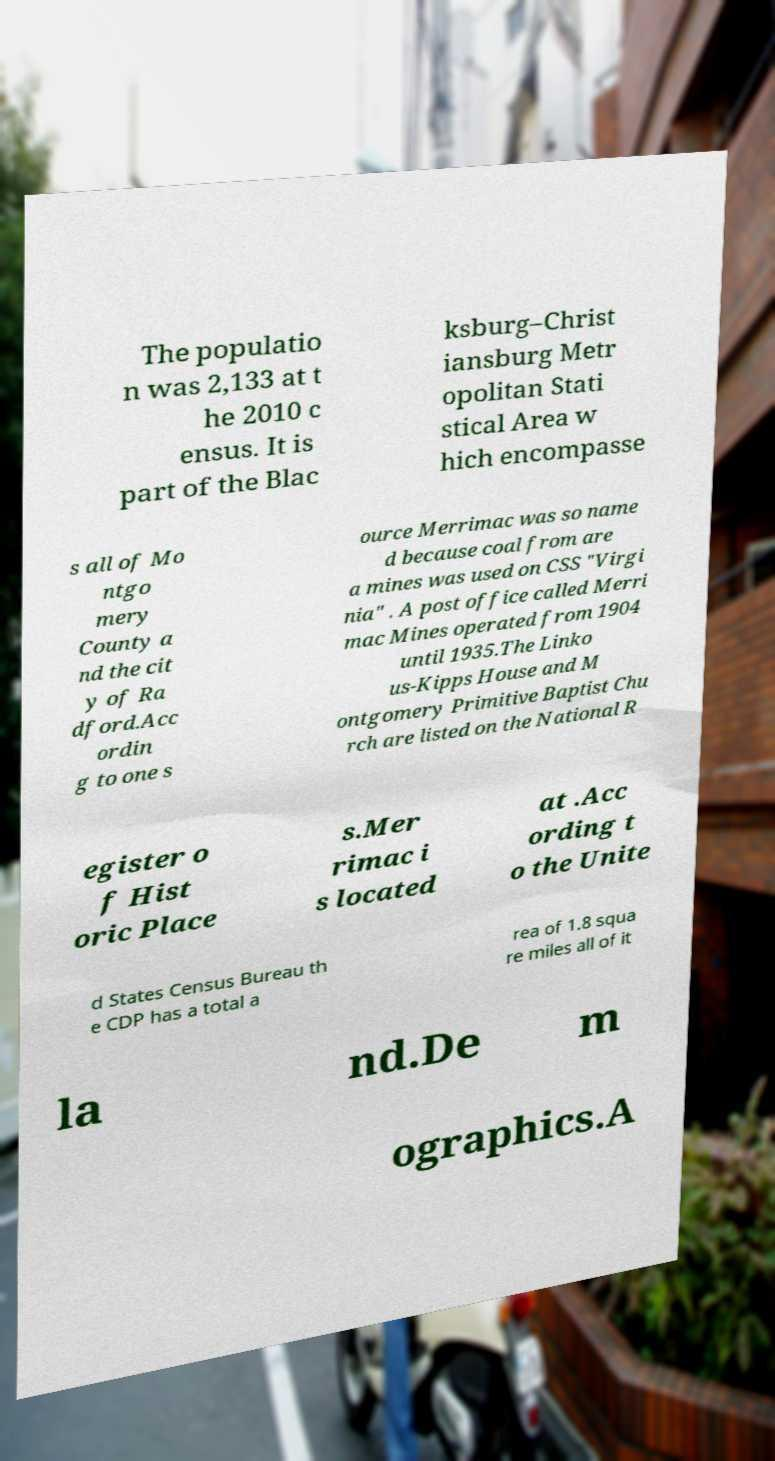I need the written content from this picture converted into text. Can you do that? The populatio n was 2,133 at t he 2010 c ensus. It is part of the Blac ksburg–Christ iansburg Metr opolitan Stati stical Area w hich encompasse s all of Mo ntgo mery County a nd the cit y of Ra dford.Acc ordin g to one s ource Merrimac was so name d because coal from are a mines was used on CSS "Virgi nia" . A post office called Merri mac Mines operated from 1904 until 1935.The Linko us-Kipps House and M ontgomery Primitive Baptist Chu rch are listed on the National R egister o f Hist oric Place s.Mer rimac i s located at .Acc ording t o the Unite d States Census Bureau th e CDP has a total a rea of 1.8 squa re miles all of it la nd.De m ographics.A 